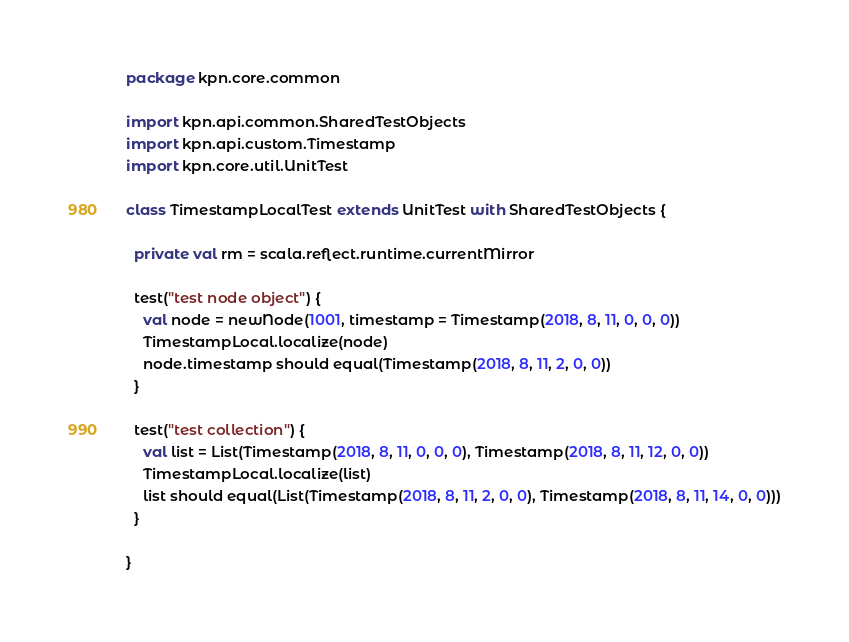<code> <loc_0><loc_0><loc_500><loc_500><_Scala_>package kpn.core.common

import kpn.api.common.SharedTestObjects
import kpn.api.custom.Timestamp
import kpn.core.util.UnitTest

class TimestampLocalTest extends UnitTest with SharedTestObjects {

  private val rm = scala.reflect.runtime.currentMirror

  test("test node object") {
    val node = newNode(1001, timestamp = Timestamp(2018, 8, 11, 0, 0, 0))
    TimestampLocal.localize(node)
    node.timestamp should equal(Timestamp(2018, 8, 11, 2, 0, 0))
  }

  test("test collection") {
    val list = List(Timestamp(2018, 8, 11, 0, 0, 0), Timestamp(2018, 8, 11, 12, 0, 0))
    TimestampLocal.localize(list)
    list should equal(List(Timestamp(2018, 8, 11, 2, 0, 0), Timestamp(2018, 8, 11, 14, 0, 0)))
  }

}
</code> 